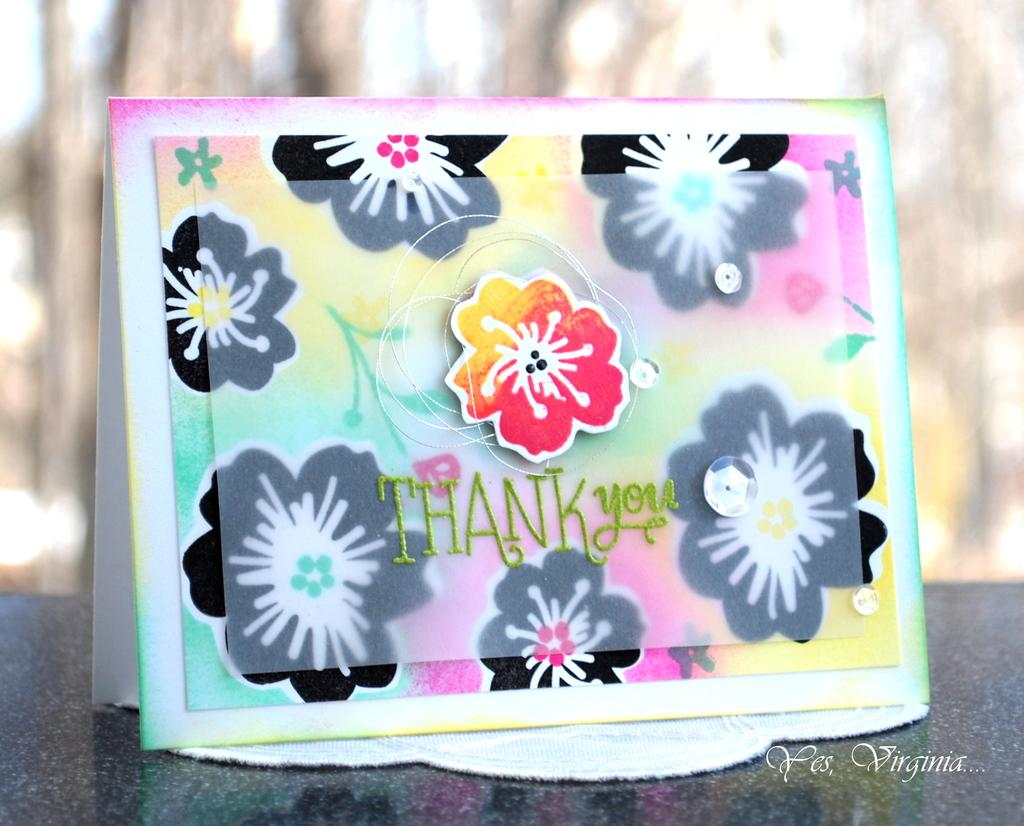What object is the main focus of the image? There is a thank you card in the image. Where is the thank you card located? The thank you card is on a table. Can you describe the background of the image? The background of the image is blurry. What type of lawyer is holding a stick in the image? There is no lawyer or stick present in the image; it only features a thank you card on a table with a blurry background. 